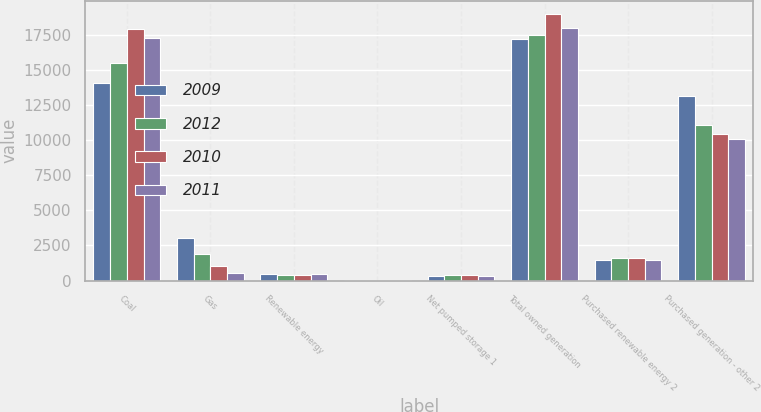Convert chart to OTSL. <chart><loc_0><loc_0><loc_500><loc_500><stacked_bar_chart><ecel><fcel>Coal<fcel>Gas<fcel>Renewable energy<fcel>Oil<fcel>Net pumped storage 1<fcel>Total owned generation<fcel>Purchased renewable energy 2<fcel>Purchased generation - other 2<nl><fcel>2009<fcel>14027<fcel>3003<fcel>433<fcel>6<fcel>295<fcel>17174<fcel>1435<fcel>13104<nl><fcel>2012<fcel>15468<fcel>1912<fcel>425<fcel>7<fcel>365<fcel>17447<fcel>1587<fcel>11087<nl><fcel>2010<fcel>17879<fcel>1043<fcel>365<fcel>21<fcel>366<fcel>18942<fcel>1582<fcel>10421<nl><fcel>2011<fcel>17255<fcel>565<fcel>466<fcel>14<fcel>303<fcel>17997<fcel>1472<fcel>10066<nl></chart> 